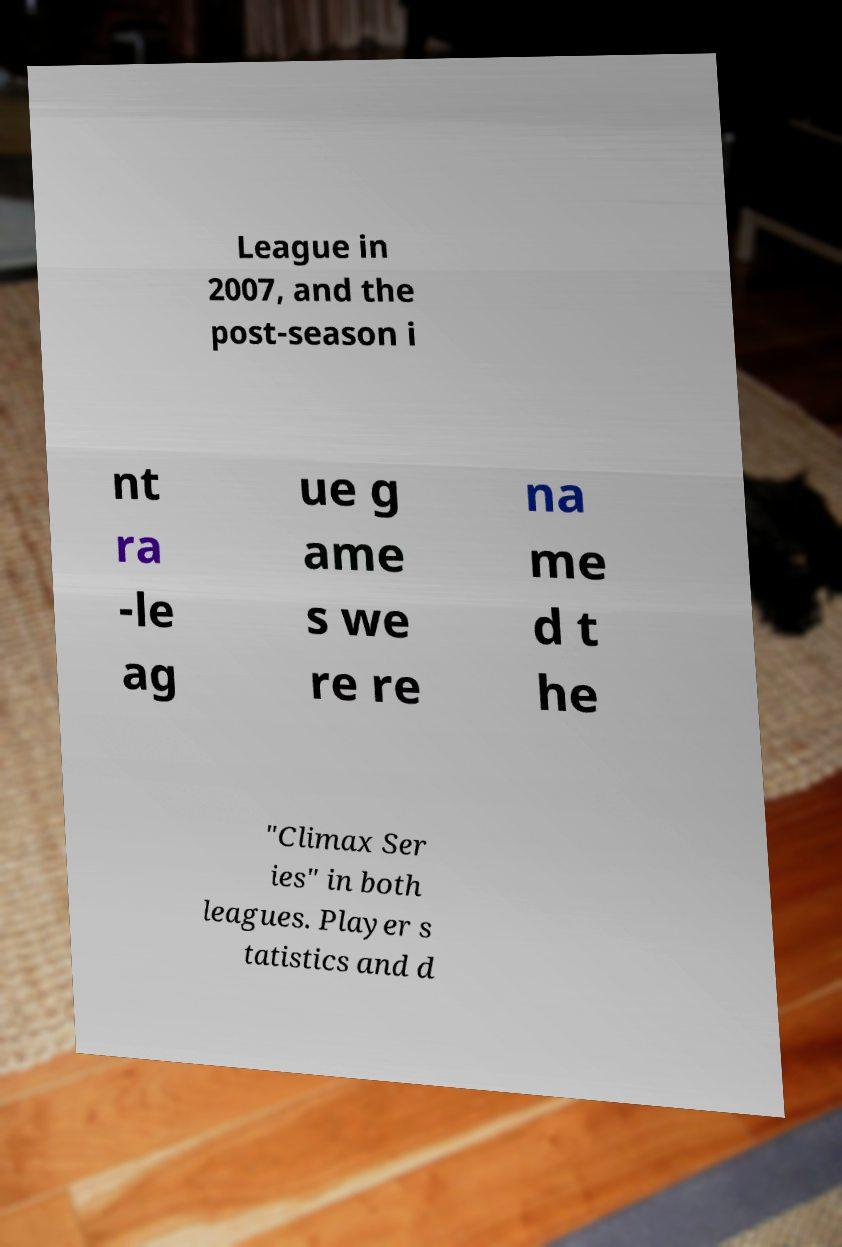Can you read and provide the text displayed in the image?This photo seems to have some interesting text. Can you extract and type it out for me? League in 2007, and the post-season i nt ra -le ag ue g ame s we re re na me d t he "Climax Ser ies" in both leagues. Player s tatistics and d 